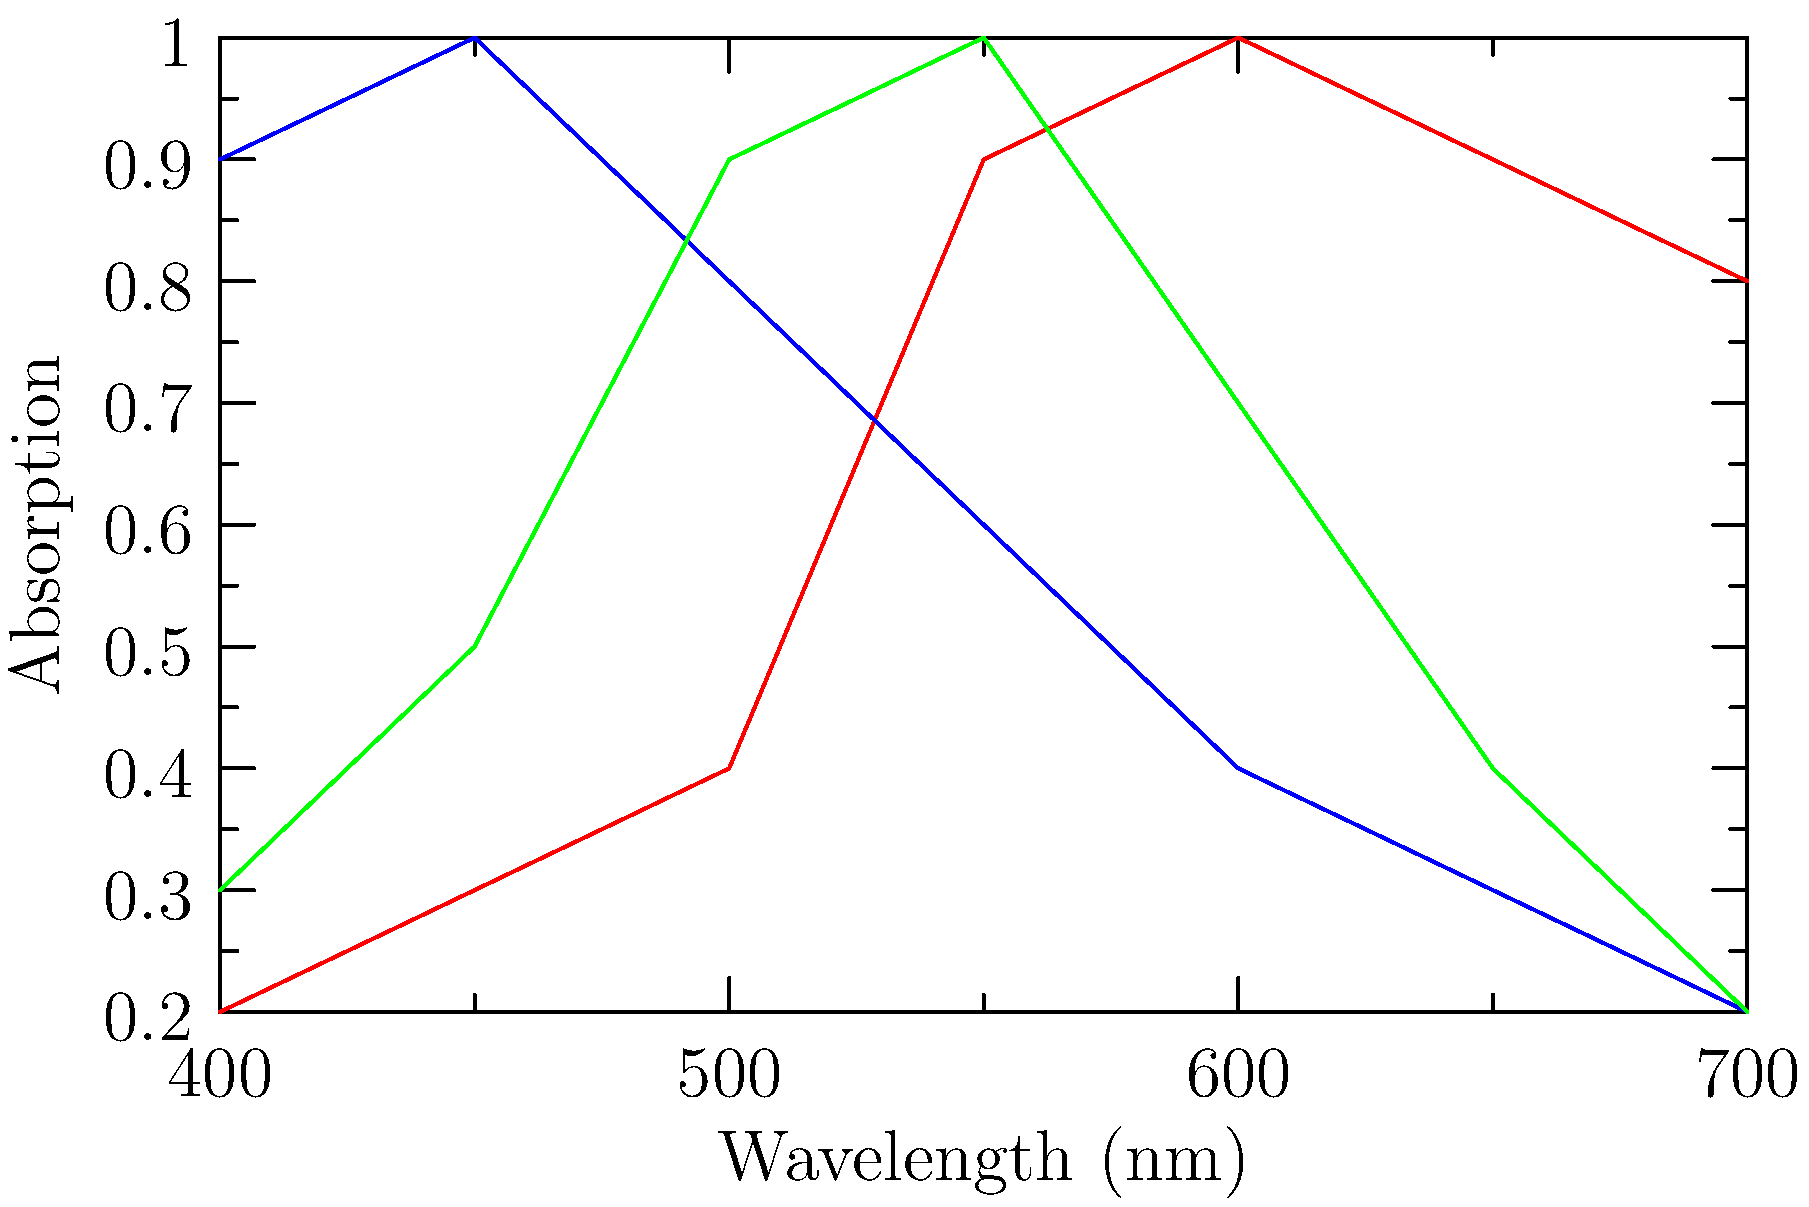As a beauty blogger educating followers on tattoo aftercare, you're exploring the science behind tattoo ink colors. The graph shows the absorption spectra of red, blue, and green tattoo inks. Which ink color absorbs light most strongly in the 600-700 nm range, and how might this affect the appearance and longevity of the tattoo? To answer this question, we need to analyze the graph and understand the relationship between light absorption and color appearance:

1. Examine the graph: The x-axis represents wavelengths of light (400-700 nm), and the y-axis represents absorption.

2. Identify the 600-700 nm range: This corresponds to orange and red light in the visible spectrum.

3. Compare absorption levels in the 600-700 nm range:
   - Red ink: High absorption (0.8-1.0)
   - Blue ink: Low absorption (0.2-0.3)
   - Green ink: Low to moderate absorption (0.2-0.4)

4. Determine the ink with the highest absorption: Red ink absorbs most strongly in this range.

5. Effect on appearance: 
   - Red ink absorbs red light, reflecting other colors, making it appear red.
   - High absorption means less light is reflected, resulting in a more vibrant and opaque appearance.

6. Effect on longevity:
   - Higher absorption can lead to more energy being absorbed by the ink.
   - This may cause the ink to break down faster over time, potentially affecting the tattoo's longevity.

In the context of tattoo aftercare, understanding these properties can help in advising clients on how different colors may age and how to best protect their tattoos from light exposure.
Answer: Red ink; may appear more vibrant but potentially fade faster due to high light absorption. 